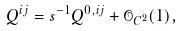<formula> <loc_0><loc_0><loc_500><loc_500>Q ^ { i j } = s ^ { - 1 } Q ^ { 0 , i j } + \mathcal { O } _ { C ^ { 2 } } ( 1 ) ,</formula> 